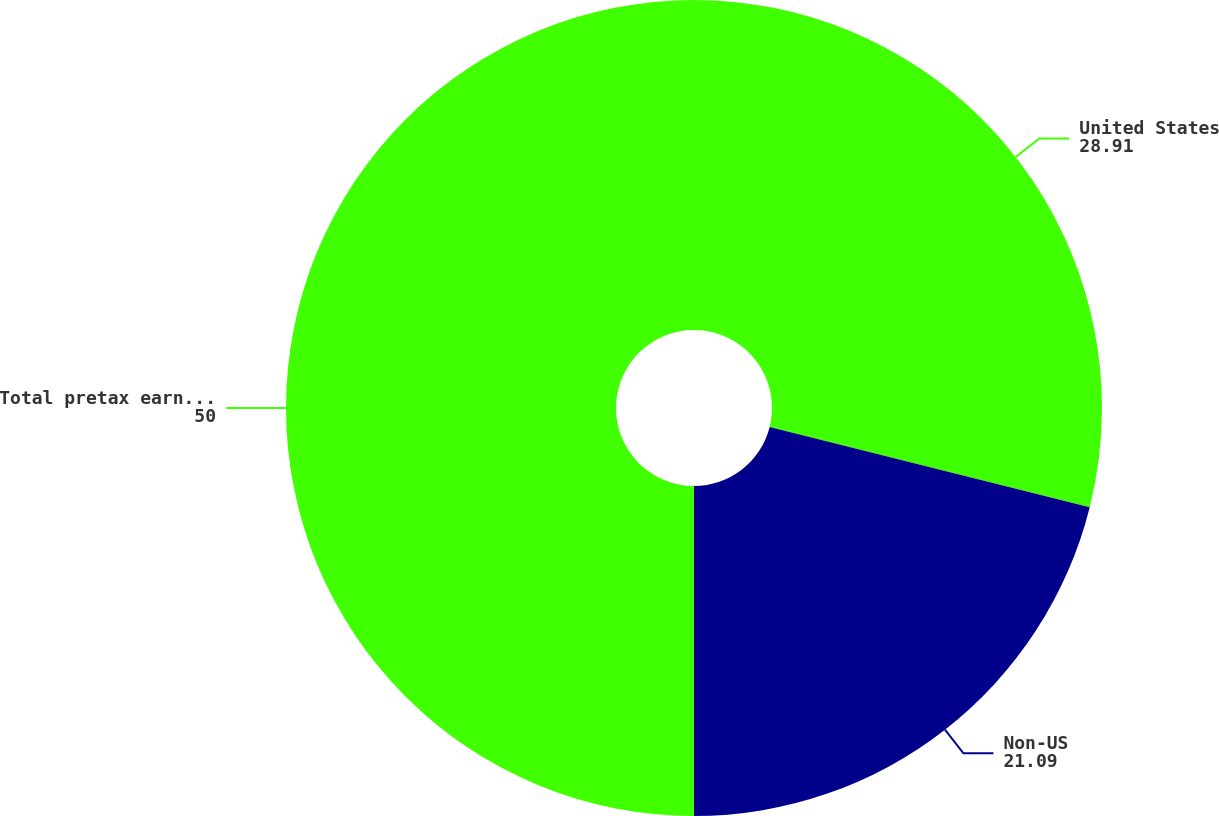<chart> <loc_0><loc_0><loc_500><loc_500><pie_chart><fcel>United States<fcel>Non-US<fcel>Total pretax earnings<nl><fcel>28.91%<fcel>21.09%<fcel>50.0%<nl></chart> 